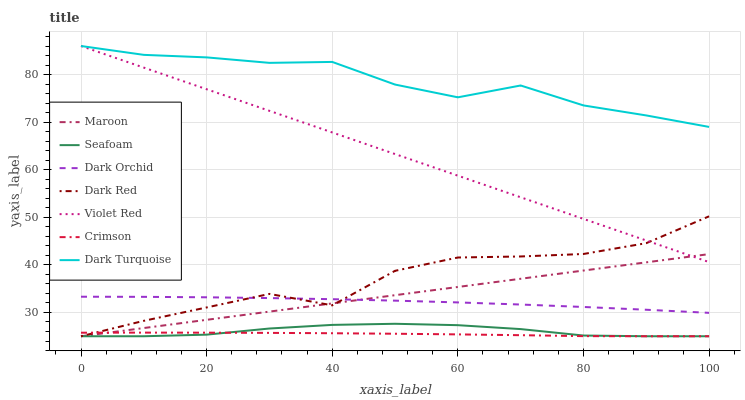Does Crimson have the minimum area under the curve?
Answer yes or no. Yes. Does Dark Turquoise have the maximum area under the curve?
Answer yes or no. Yes. Does Dark Red have the minimum area under the curve?
Answer yes or no. No. Does Dark Red have the maximum area under the curve?
Answer yes or no. No. Is Maroon the smoothest?
Answer yes or no. Yes. Is Dark Red the roughest?
Answer yes or no. Yes. Is Seafoam the smoothest?
Answer yes or no. No. Is Seafoam the roughest?
Answer yes or no. No. Does Dark Red have the lowest value?
Answer yes or no. Yes. Does Dark Orchid have the lowest value?
Answer yes or no. No. Does Dark Turquoise have the highest value?
Answer yes or no. Yes. Does Dark Red have the highest value?
Answer yes or no. No. Is Crimson less than Violet Red?
Answer yes or no. Yes. Is Violet Red greater than Crimson?
Answer yes or no. Yes. Does Dark Red intersect Seafoam?
Answer yes or no. Yes. Is Dark Red less than Seafoam?
Answer yes or no. No. Is Dark Red greater than Seafoam?
Answer yes or no. No. Does Crimson intersect Violet Red?
Answer yes or no. No. 